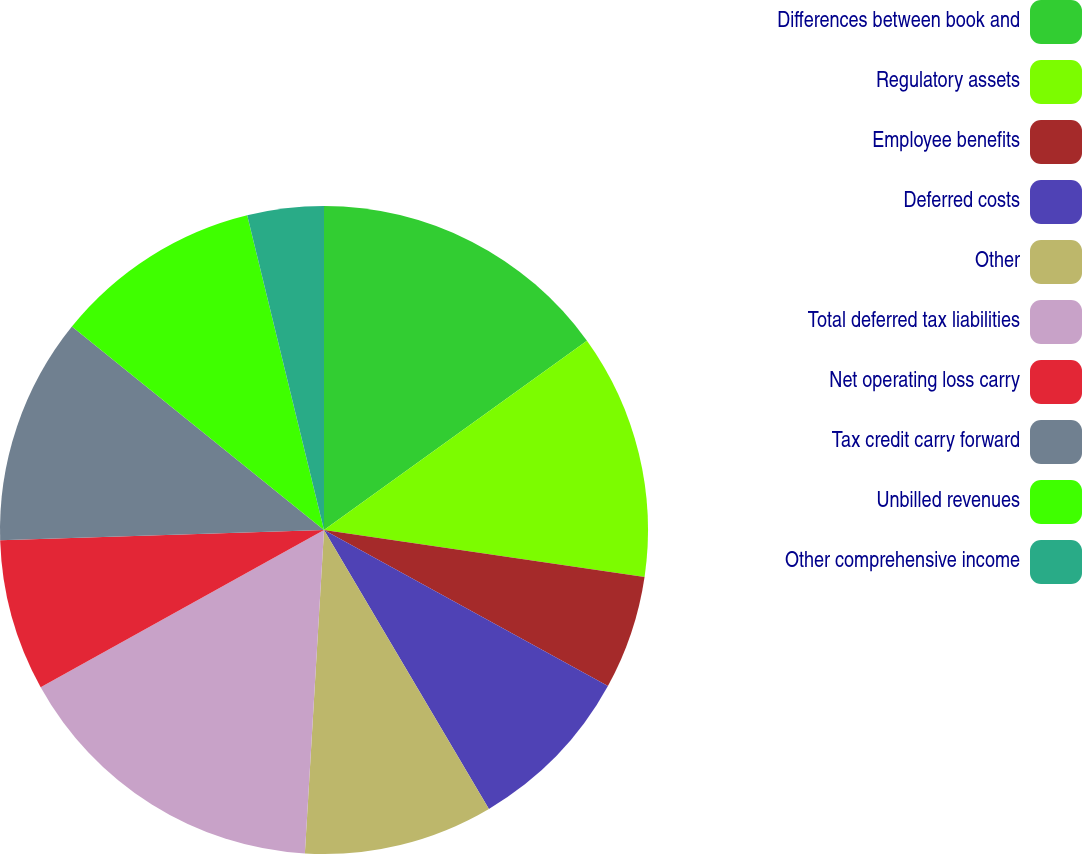<chart> <loc_0><loc_0><loc_500><loc_500><pie_chart><fcel>Differences between book and<fcel>Regulatory assets<fcel>Employee benefits<fcel>Deferred costs<fcel>Other<fcel>Total deferred tax liabilities<fcel>Net operating loss carry<fcel>Tax credit carry forward<fcel>Unbilled revenues<fcel>Other comprehensive income<nl><fcel>15.07%<fcel>12.25%<fcel>5.68%<fcel>8.5%<fcel>9.44%<fcel>16.0%<fcel>7.56%<fcel>11.31%<fcel>10.38%<fcel>3.81%<nl></chart> 